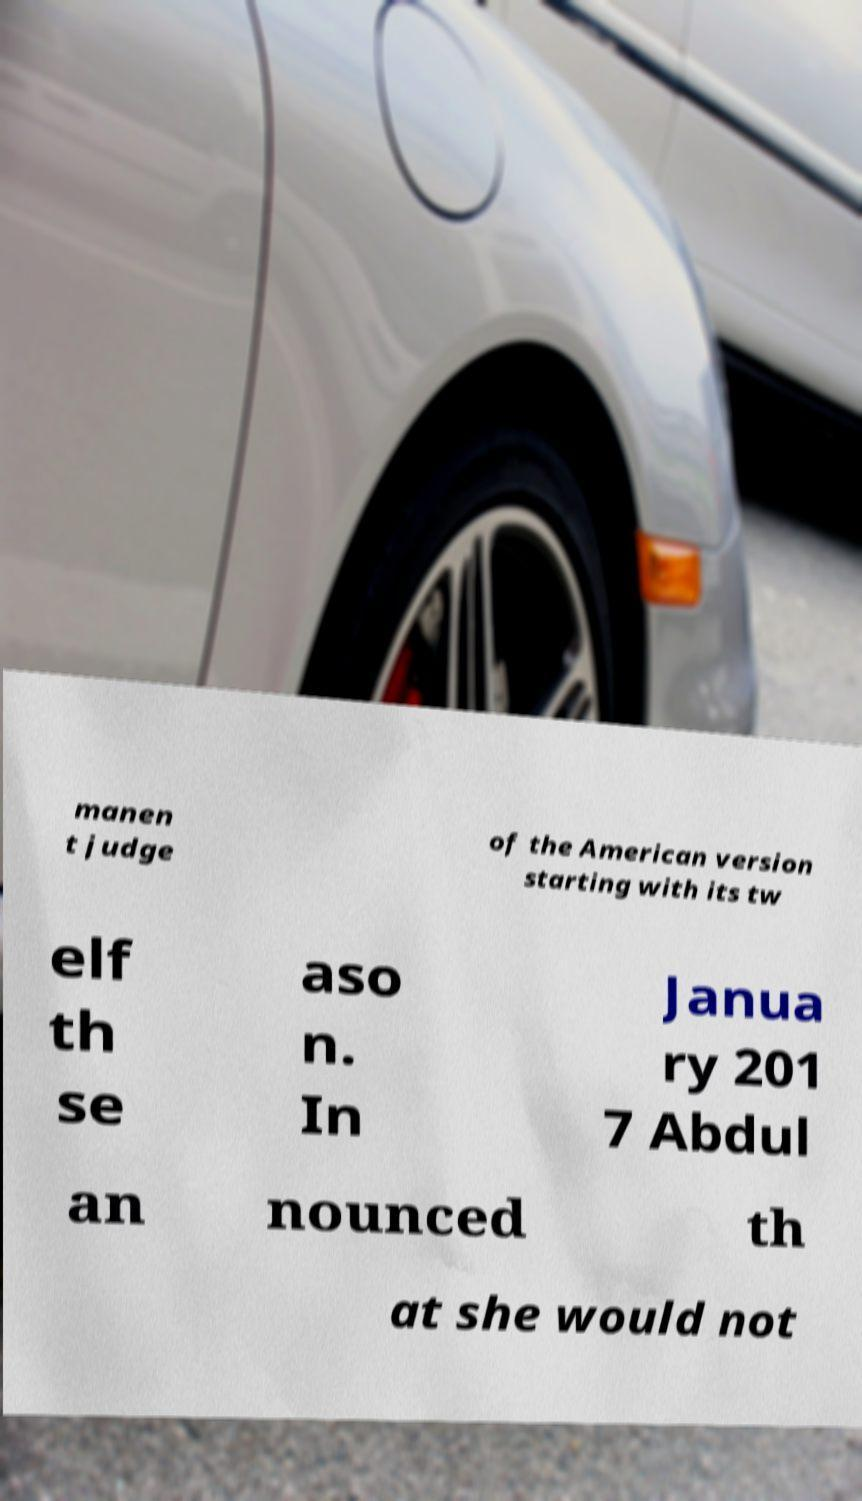Can you accurately transcribe the text from the provided image for me? manen t judge of the American version starting with its tw elf th se aso n. In Janua ry 201 7 Abdul an nounced th at she would not 